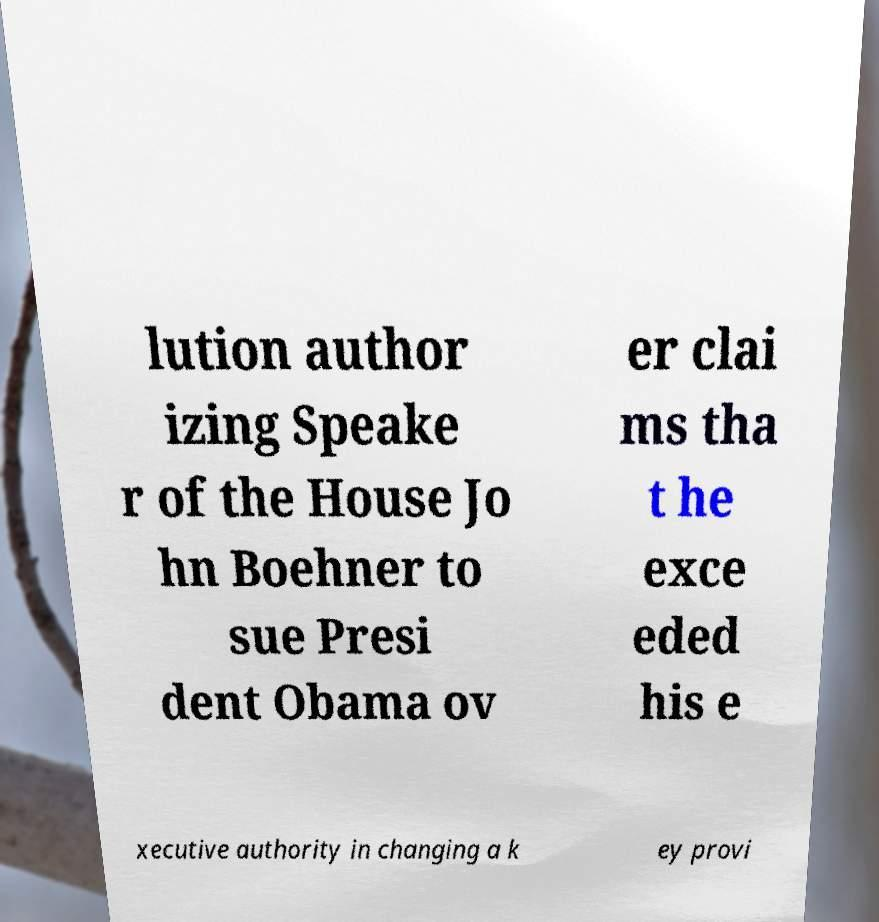What messages or text are displayed in this image? I need them in a readable, typed format. lution author izing Speake r of the House Jo hn Boehner to sue Presi dent Obama ov er clai ms tha t he exce eded his e xecutive authority in changing a k ey provi 